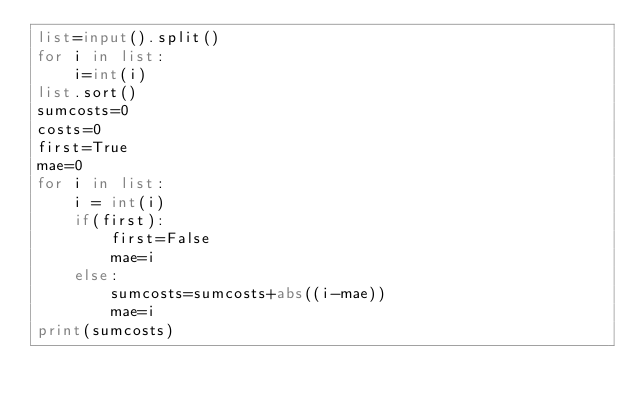Convert code to text. <code><loc_0><loc_0><loc_500><loc_500><_Python_>list=input().split()
for i in list:
    i=int(i)
list.sort()
sumcosts=0
costs=0
first=True
mae=0
for i in list:
    i = int(i)
    if(first):
        first=False
        mae=i
    else:
        sumcosts=sumcosts+abs((i-mae))
        mae=i
print(sumcosts)

</code> 